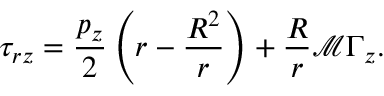Convert formula to latex. <formula><loc_0><loc_0><loc_500><loc_500>\tau _ { r z } = \frac { p _ { z } } { 2 } \left ( r - \frac { R ^ { 2 } } { r } \right ) + \frac { R } { r } \mathcal { M } \Gamma _ { z } .</formula> 